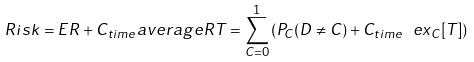<formula> <loc_0><loc_0><loc_500><loc_500>R i s k = E R + C _ { t i m e } a v e r a g e R T = \sum _ { C = 0 } ^ { 1 } \left ( P _ { C } ( D \neq C ) + C _ { t i m e } \ e x _ { C } [ T ] \right )</formula> 